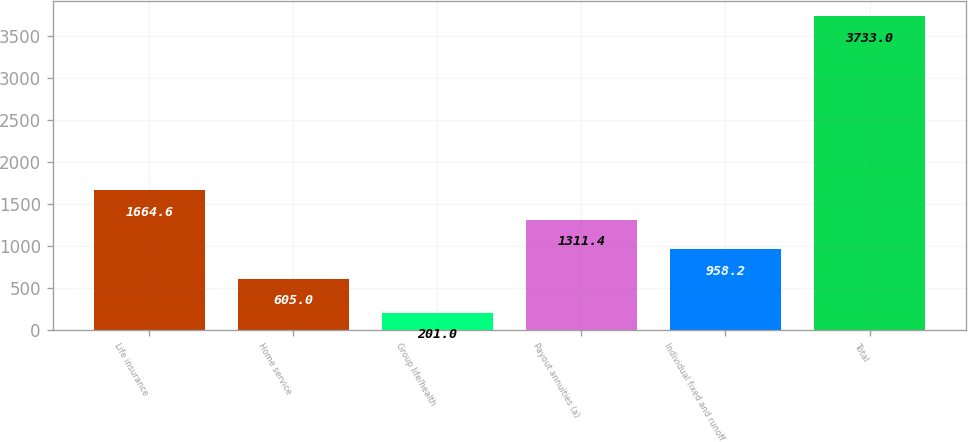Convert chart. <chart><loc_0><loc_0><loc_500><loc_500><bar_chart><fcel>Life insurance<fcel>Home service<fcel>Group life/health<fcel>Payout annuities (a)<fcel>Individual fixed and runoff<fcel>Total<nl><fcel>1664.6<fcel>605<fcel>201<fcel>1311.4<fcel>958.2<fcel>3733<nl></chart> 